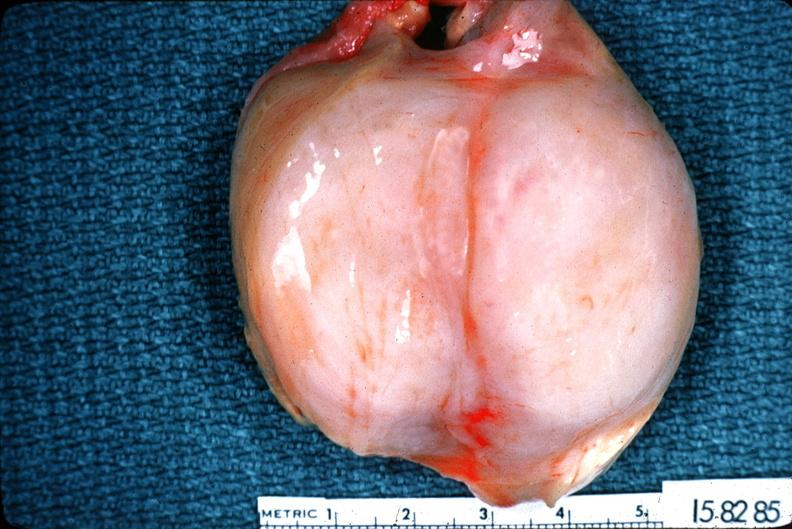what does this image show?
Answer the question using a single word or phrase. Schwannoma 